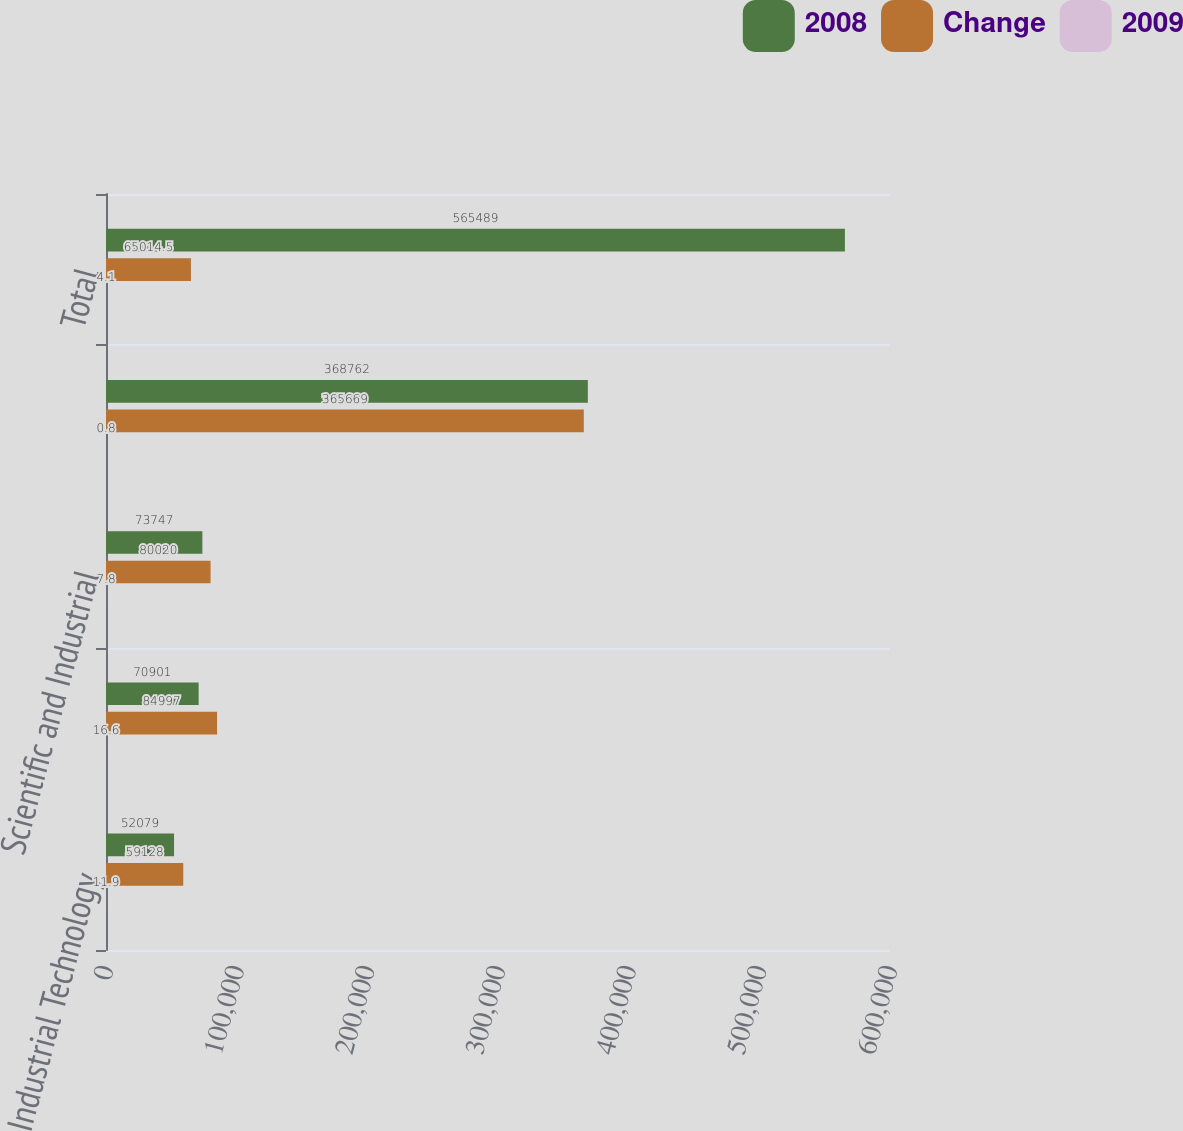Convert chart to OTSL. <chart><loc_0><loc_0><loc_500><loc_500><stacked_bar_chart><ecel><fcel>Industrial Technology<fcel>Energy Systems and Controls<fcel>Scientific and Industrial<fcel>RF Technology<fcel>Total<nl><fcel>2008<fcel>52079<fcel>70901<fcel>73747<fcel>368762<fcel>565489<nl><fcel>Change<fcel>59128<fcel>84997<fcel>80020<fcel>365669<fcel>65014.5<nl><fcel>2009<fcel>11.9<fcel>16.6<fcel>7.8<fcel>0.8<fcel>4.1<nl></chart> 